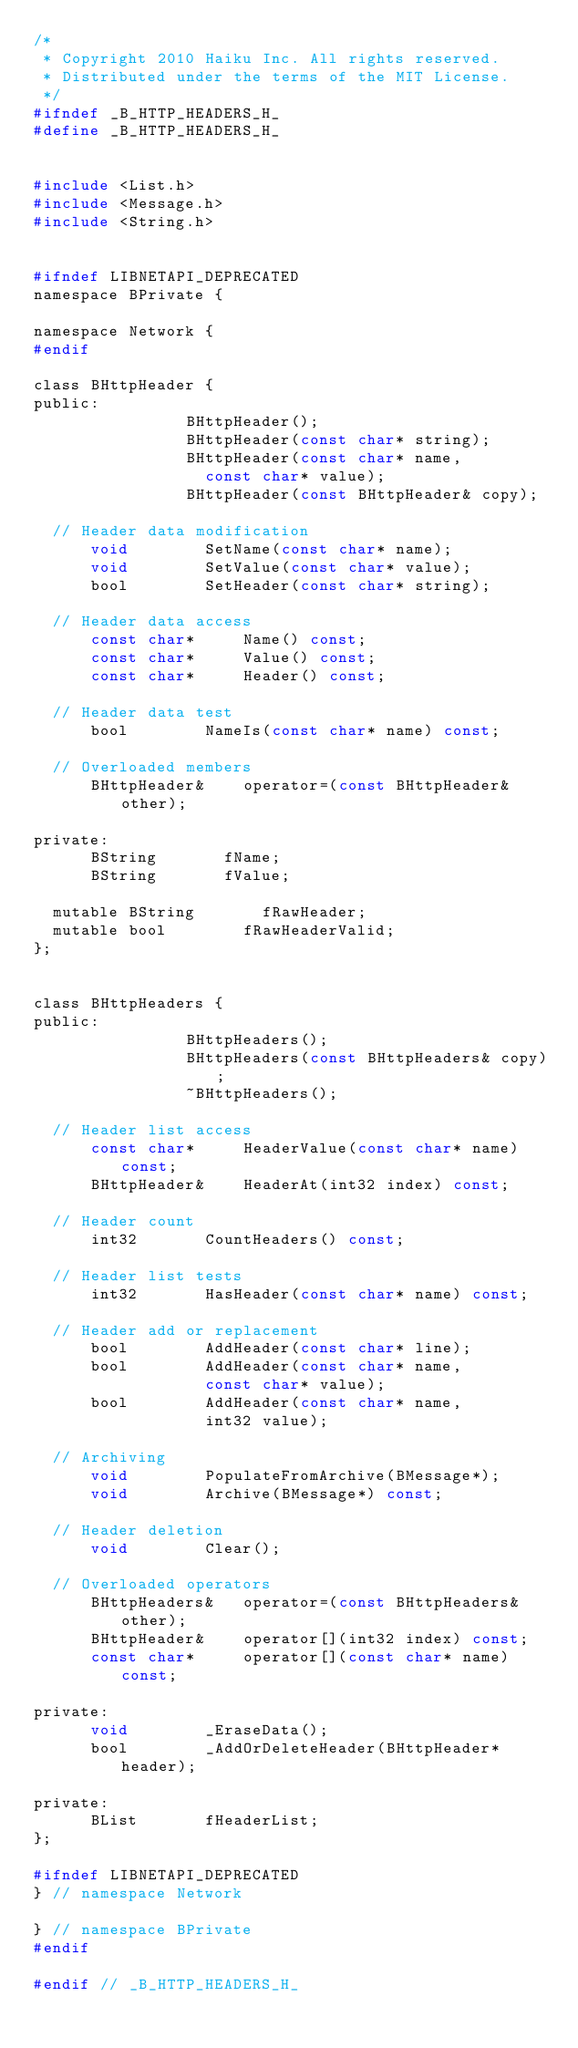<code> <loc_0><loc_0><loc_500><loc_500><_C_>/*
 * Copyright 2010 Haiku Inc. All rights reserved.
 * Distributed under the terms of the MIT License.
 */
#ifndef _B_HTTP_HEADERS_H_
#define _B_HTTP_HEADERS_H_


#include <List.h>
#include <Message.h>
#include <String.h>


#ifndef LIBNETAPI_DEPRECATED
namespace BPrivate {

namespace Network {
#endif

class BHttpHeader {
public:
								BHttpHeader();
								BHttpHeader(const char* string);
								BHttpHeader(const char* name,
									const char* value);
								BHttpHeader(const BHttpHeader& copy);

	// Header data modification
			void				SetName(const char* name);
			void				SetValue(const char* value);
			bool				SetHeader(const char* string);

	// Header data access
			const char*			Name() const;
			const char*			Value() const;
			const char*			Header() const;

	// Header data test
			bool				NameIs(const char* name) const;

	// Overloaded members
			BHttpHeader&		operator=(const BHttpHeader& other);

private:
			BString				fName;
			BString				fValue;

	mutable	BString				fRawHeader;
	mutable	bool				fRawHeaderValid;
};


class BHttpHeaders {
public:
								BHttpHeaders();
								BHttpHeaders(const BHttpHeaders& copy);
								~BHttpHeaders();

	// Header list access
			const char*			HeaderValue(const char* name) const;
			BHttpHeader&		HeaderAt(int32 index) const;

	// Header count
			int32				CountHeaders() const;

	// Header list tests
			int32				HasHeader(const char* name) const;

	// Header add or replacement
			bool				AddHeader(const char* line);
			bool				AddHeader(const char* name,
									const char* value);
			bool				AddHeader(const char* name,
									int32 value);

	// Archiving
			void				PopulateFromArchive(BMessage*);
			void				Archive(BMessage*) const;

	// Header deletion
			void				Clear();

	// Overloaded operators
			BHttpHeaders&		operator=(const BHttpHeaders& other);
			BHttpHeader&		operator[](int32 index) const;
			const char*			operator[](const char* name) const;

private:
			void				_EraseData();
			bool				_AddOrDeleteHeader(BHttpHeader* header);

private:
			BList				fHeaderList;
};

#ifndef LIBNETAPI_DEPRECATED
} // namespace Network

} // namespace BPrivate
#endif

#endif // _B_HTTP_HEADERS_H_
</code> 